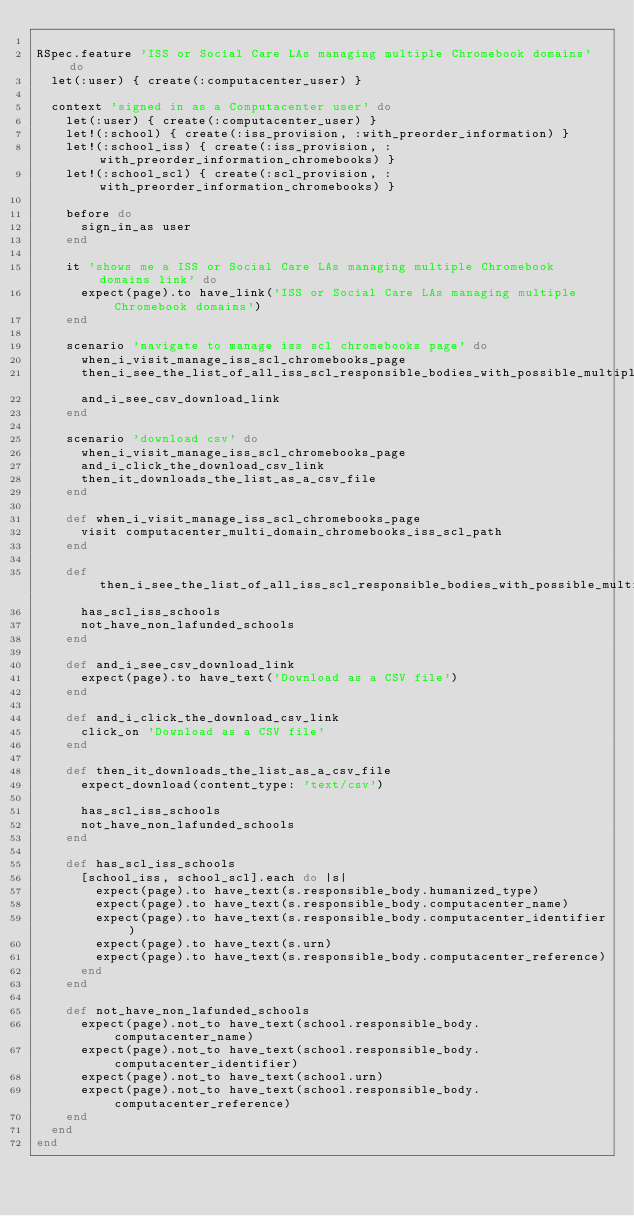<code> <loc_0><loc_0><loc_500><loc_500><_Ruby_>
RSpec.feature 'ISS or Social Care LAs managing multiple Chromebook domains' do
  let(:user) { create(:computacenter_user) }

  context 'signed in as a Computacenter user' do
    let(:user) { create(:computacenter_user) }
    let!(:school) { create(:iss_provision, :with_preorder_information) }
    let!(:school_iss) { create(:iss_provision, :with_preorder_information_chromebooks) }
    let!(:school_scl) { create(:scl_provision, :with_preorder_information_chromebooks) }

    before do
      sign_in_as user
    end

    it 'shows me a ISS or Social Care LAs managing multiple Chromebook domains link' do
      expect(page).to have_link('ISS or Social Care LAs managing multiple Chromebook domains')
    end

    scenario 'navigate to manage iss scl chromebooks page' do
      when_i_visit_manage_iss_scl_chromebooks_page
      then_i_see_the_list_of_all_iss_scl_responsible_bodies_with_possible_multiple_domains
      and_i_see_csv_download_link
    end

    scenario 'download csv' do
      when_i_visit_manage_iss_scl_chromebooks_page
      and_i_click_the_download_csv_link
      then_it_downloads_the_list_as_a_csv_file
    end

    def when_i_visit_manage_iss_scl_chromebooks_page
      visit computacenter_multi_domain_chromebooks_iss_scl_path
    end

    def then_i_see_the_list_of_all_iss_scl_responsible_bodies_with_possible_multiple_domains
      has_scl_iss_schools
      not_have_non_lafunded_schools
    end

    def and_i_see_csv_download_link
      expect(page).to have_text('Download as a CSV file')
    end

    def and_i_click_the_download_csv_link
      click_on 'Download as a CSV file'
    end

    def then_it_downloads_the_list_as_a_csv_file
      expect_download(content_type: 'text/csv')

      has_scl_iss_schools
      not_have_non_lafunded_schools
    end

    def has_scl_iss_schools
      [school_iss, school_scl].each do |s|
        expect(page).to have_text(s.responsible_body.humanized_type)
        expect(page).to have_text(s.responsible_body.computacenter_name)
        expect(page).to have_text(s.responsible_body.computacenter_identifier)
        expect(page).to have_text(s.urn)
        expect(page).to have_text(s.responsible_body.computacenter_reference)
      end
    end

    def not_have_non_lafunded_schools
      expect(page).not_to have_text(school.responsible_body.computacenter_name)
      expect(page).not_to have_text(school.responsible_body.computacenter_identifier)
      expect(page).not_to have_text(school.urn)
      expect(page).not_to have_text(school.responsible_body.computacenter_reference)
    end
  end
end
</code> 